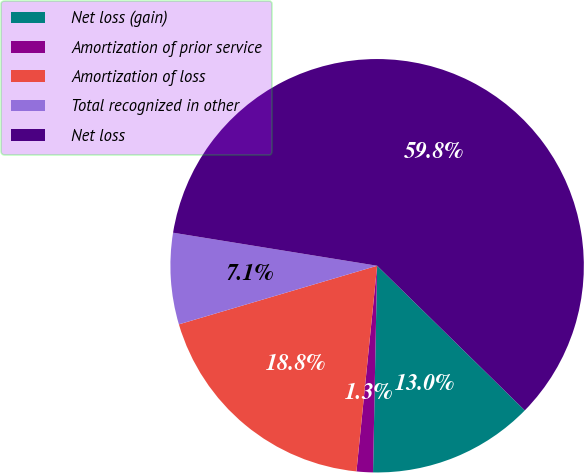Convert chart. <chart><loc_0><loc_0><loc_500><loc_500><pie_chart><fcel>Net loss (gain)<fcel>Amortization of prior service<fcel>Amortization of loss<fcel>Total recognized in other<fcel>Net loss<nl><fcel>12.98%<fcel>1.28%<fcel>18.83%<fcel>7.13%<fcel>59.78%<nl></chart> 